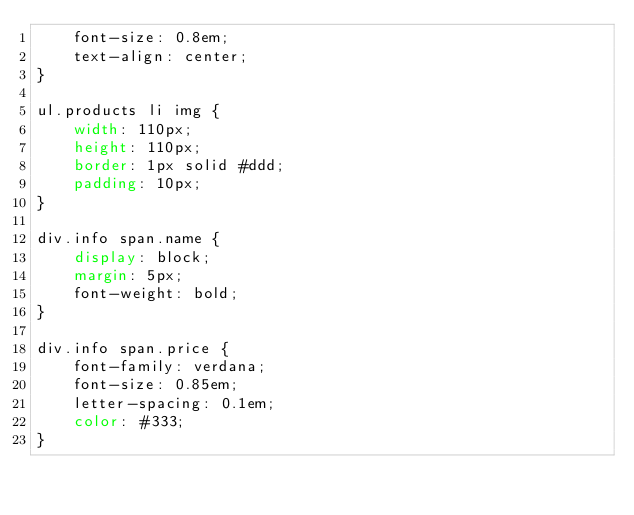<code> <loc_0><loc_0><loc_500><loc_500><_CSS_>    font-size: 0.8em;
    text-align: center;
}

ul.products li img {
    width: 110px;
    height: 110px;
    border: 1px solid #ddd;
    padding: 10px;
}

div.info span.name {
    display: block;
    margin: 5px;
    font-weight: bold;
}

div.info span.price {
    font-family: verdana;
    font-size: 0.85em;
    letter-spacing: 0.1em;
    color: #333;
}
</code> 